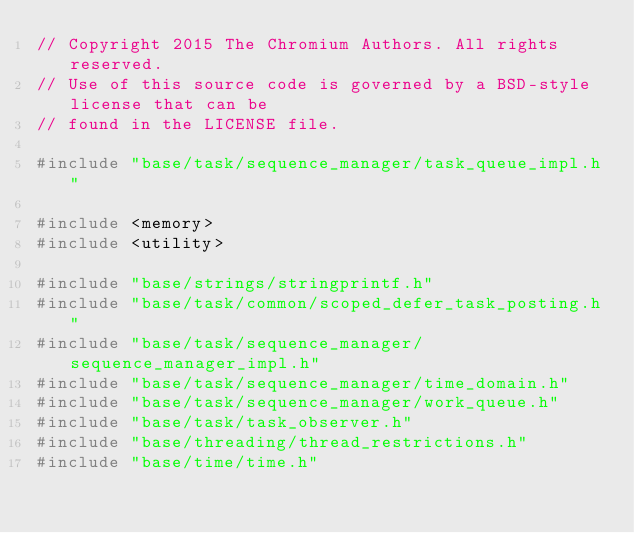<code> <loc_0><loc_0><loc_500><loc_500><_C++_>// Copyright 2015 The Chromium Authors. All rights reserved.
// Use of this source code is governed by a BSD-style license that can be
// found in the LICENSE file.

#include "base/task/sequence_manager/task_queue_impl.h"

#include <memory>
#include <utility>

#include "base/strings/stringprintf.h"
#include "base/task/common/scoped_defer_task_posting.h"
#include "base/task/sequence_manager/sequence_manager_impl.h"
#include "base/task/sequence_manager/time_domain.h"
#include "base/task/sequence_manager/work_queue.h"
#include "base/task/task_observer.h"
#include "base/threading/thread_restrictions.h"
#include "base/time/time.h"</code> 